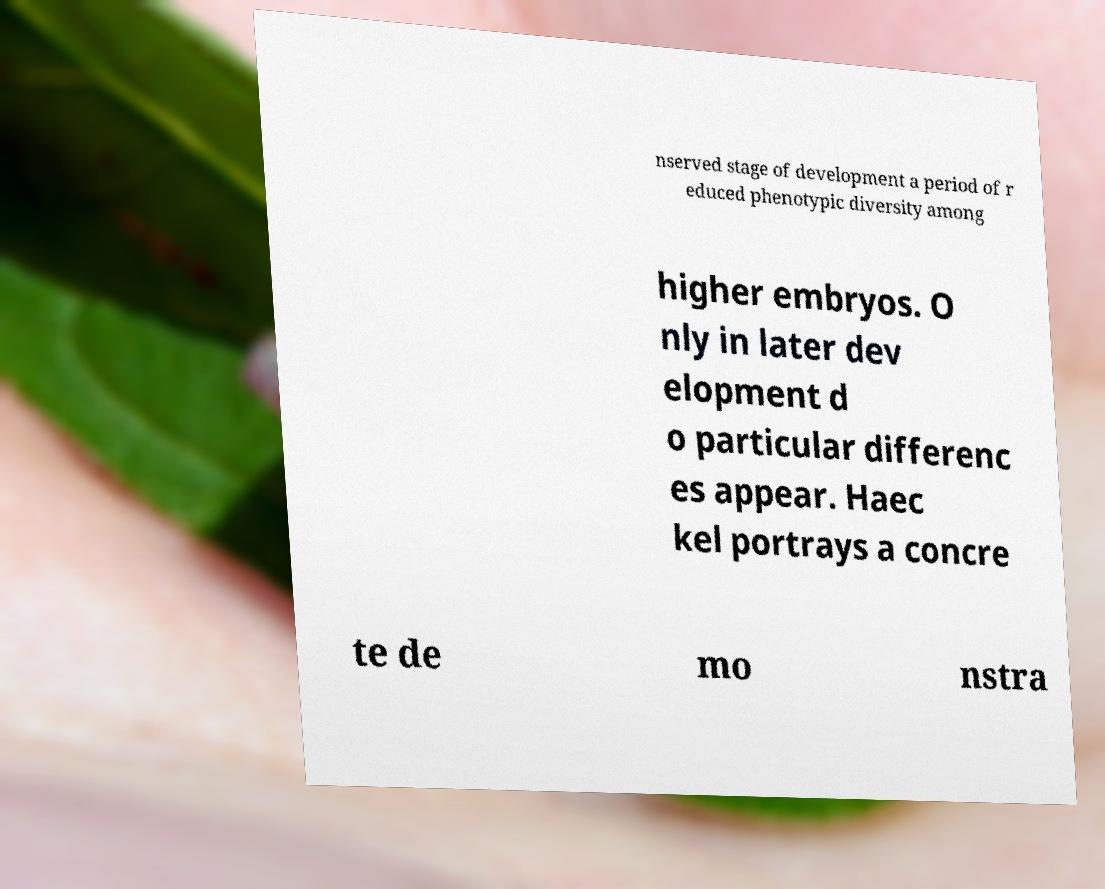Could you assist in decoding the text presented in this image and type it out clearly? nserved stage of development a period of r educed phenotypic diversity among higher embryos. O nly in later dev elopment d o particular differenc es appear. Haec kel portrays a concre te de mo nstra 